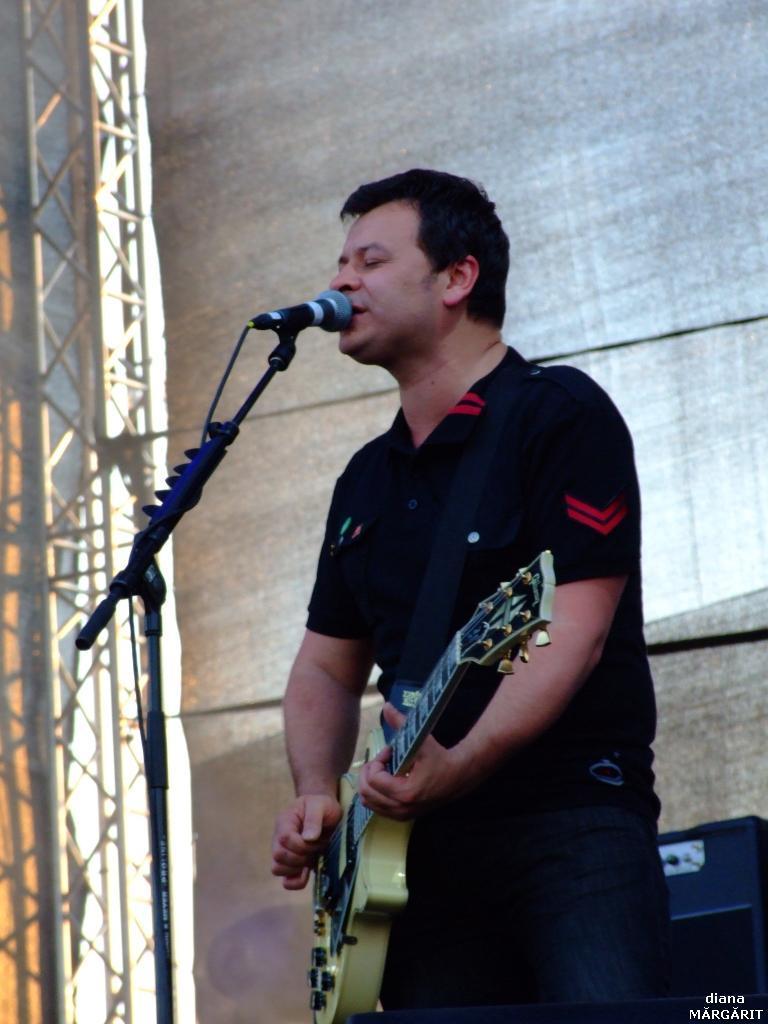How would you summarize this image in a sentence or two? In this image a person is standing and playing guitar. At left side there is a mike stand. A water mark is at the right bottom. Metal rods are at the left side of the image. 